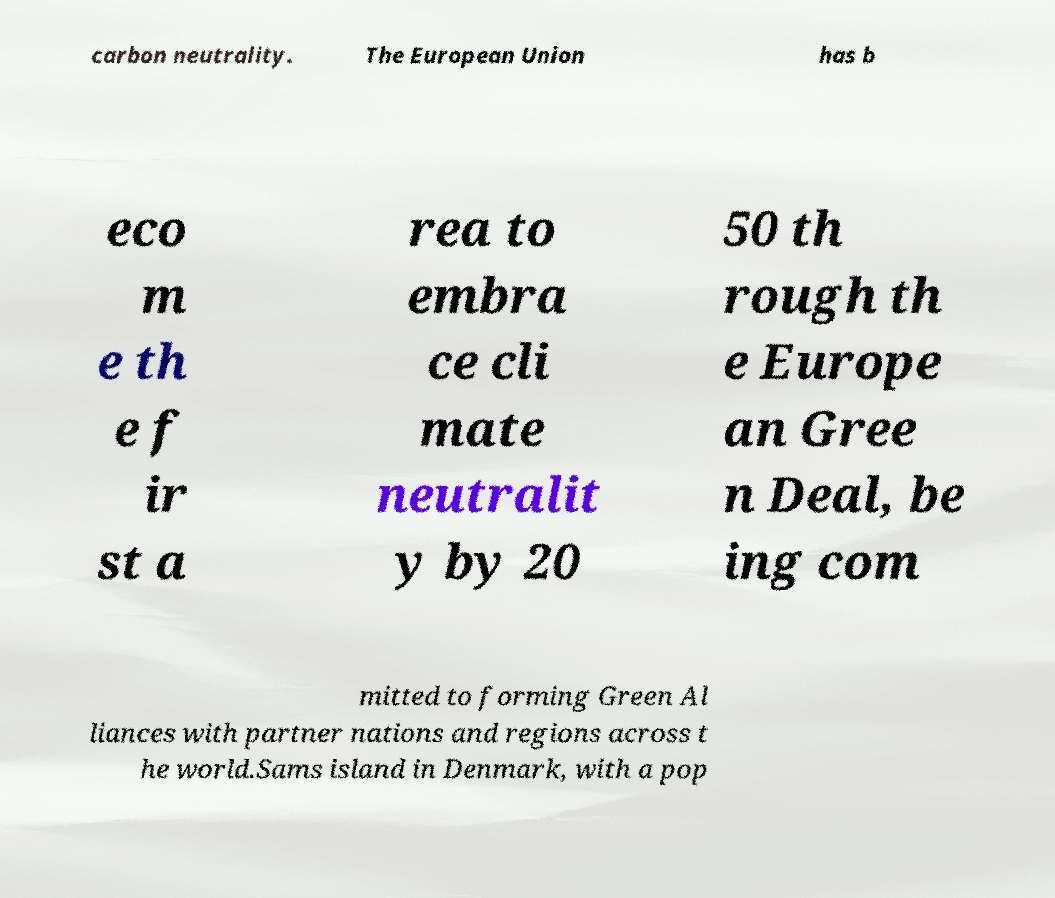Can you read and provide the text displayed in the image?This photo seems to have some interesting text. Can you extract and type it out for me? carbon neutrality. The European Union has b eco m e th e f ir st a rea to embra ce cli mate neutralit y by 20 50 th rough th e Europe an Gree n Deal, be ing com mitted to forming Green Al liances with partner nations and regions across t he world.Sams island in Denmark, with a pop 